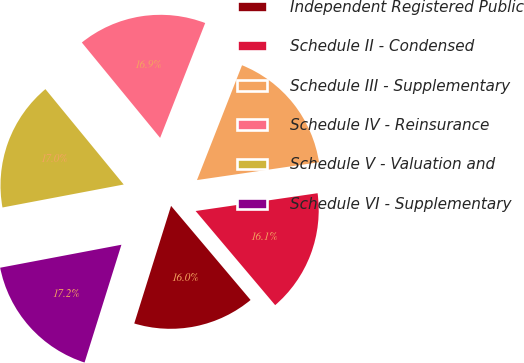Convert chart. <chart><loc_0><loc_0><loc_500><loc_500><pie_chart><fcel>Independent Registered Public<fcel>Schedule II - Condensed<fcel>Schedule III - Supplementary<fcel>Schedule IV - Reinsurance<fcel>Schedule V - Valuation and<fcel>Schedule VI - Supplementary<nl><fcel>15.99%<fcel>16.14%<fcel>16.74%<fcel>16.89%<fcel>17.04%<fcel>17.19%<nl></chart> 